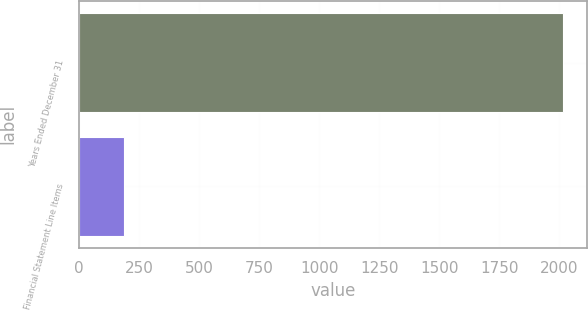<chart> <loc_0><loc_0><loc_500><loc_500><bar_chart><fcel>Years Ended December 31<fcel>Financial Statement Line Items<nl><fcel>2016<fcel>189<nl></chart> 